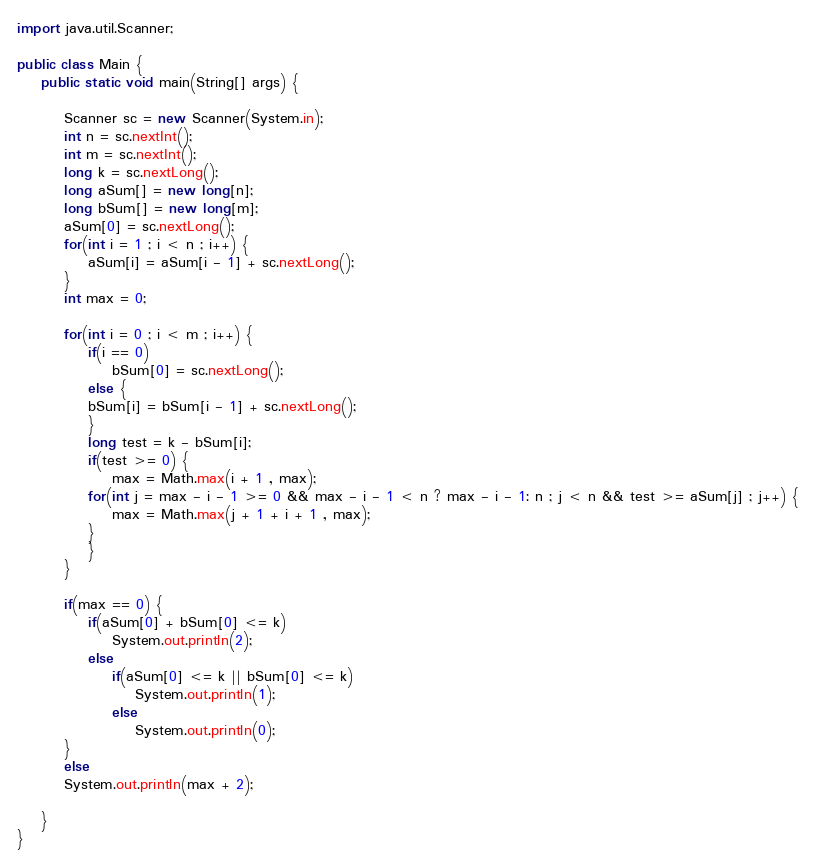<code> <loc_0><loc_0><loc_500><loc_500><_Java_>import java.util.Scanner;

public class Main {
	public static void main(String[] args) {

		Scanner sc = new Scanner(System.in);
		int n = sc.nextInt();
		int m = sc.nextInt();
		long k = sc.nextLong();
		long aSum[] = new long[n];
		long bSum[] = new long[m];
		aSum[0] = sc.nextLong();
		for(int i = 1 ; i < n ; i++) {
			aSum[i] = aSum[i - 1] + sc.nextLong();
		}
		int max = 0;

		for(int i = 0 ; i < m ; i++) {
			if(i == 0)
				bSum[0] = sc.nextLong();
			else {
			bSum[i] = bSum[i - 1] + sc.nextLong();
			}
			long test = k - bSum[i];
			if(test >= 0) {
				max = Math.max(i + 1 , max);
			for(int j = max - i - 1 >= 0 && max - i - 1 < n ? max - i - 1: n ; j < n && test >= aSum[j] ; j++) {
				max = Math.max(j + 1 + i + 1 , max);
			}
			}
		}

		if(max == 0) {
			if(aSum[0] + bSum[0] <= k)
				System.out.println(2);
			else
				if(aSum[0] <= k || bSum[0] <= k)
					System.out.println(1);
				else
					System.out.println(0);
		}
		else
		System.out.println(max + 2);

	}
}

</code> 